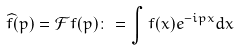Convert formula to latex. <formula><loc_0><loc_0><loc_500><loc_500>\widehat { f } ( p ) = \mathcal { F } f ( p ) \colon = \int f ( x ) e ^ { - i p x } d x</formula> 